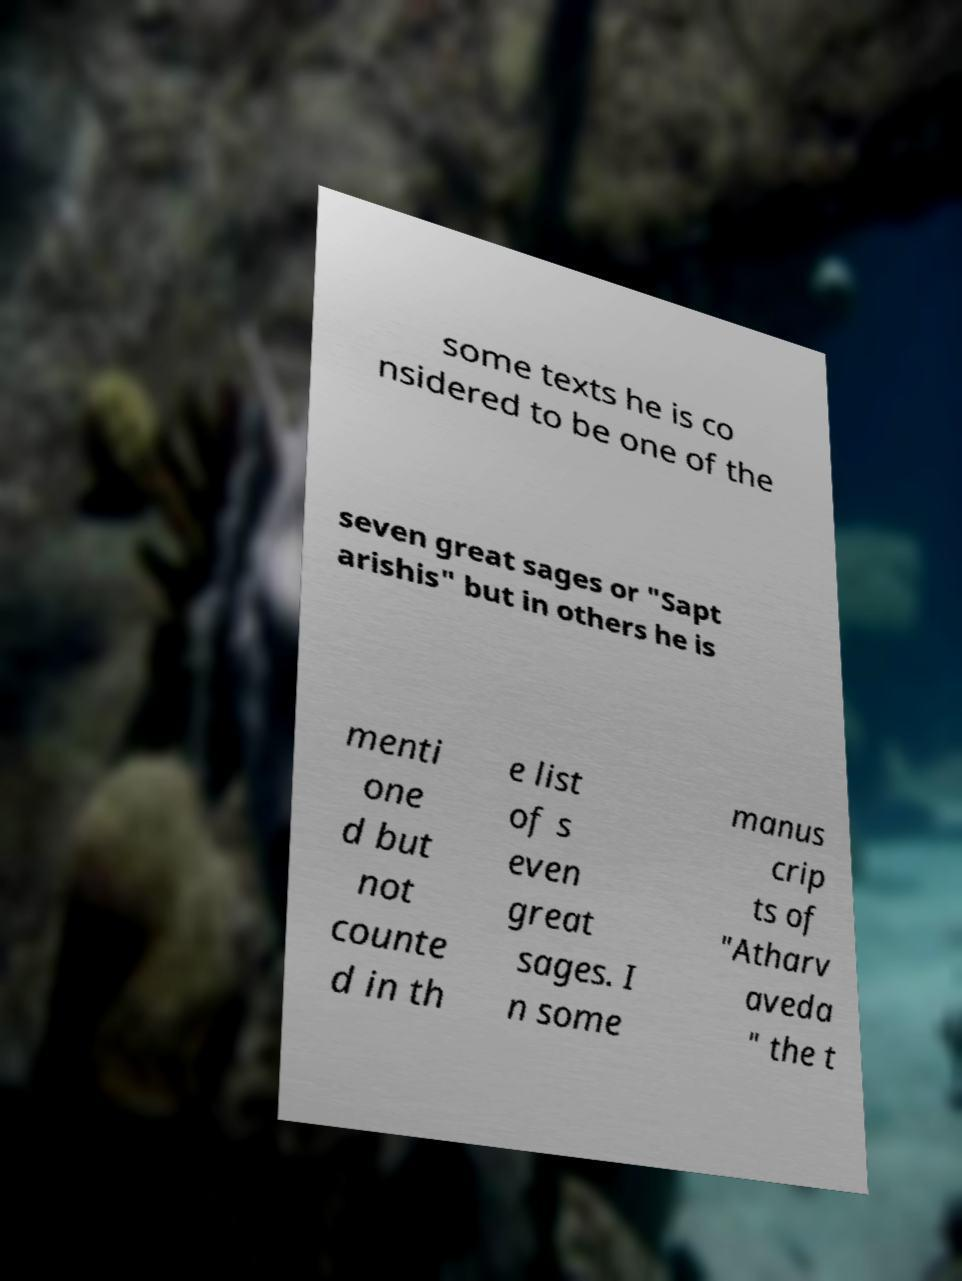Could you extract and type out the text from this image? some texts he is co nsidered to be one of the seven great sages or "Sapt arishis" but in others he is menti one d but not counte d in th e list of s even great sages. I n some manus crip ts of "Atharv aveda " the t 